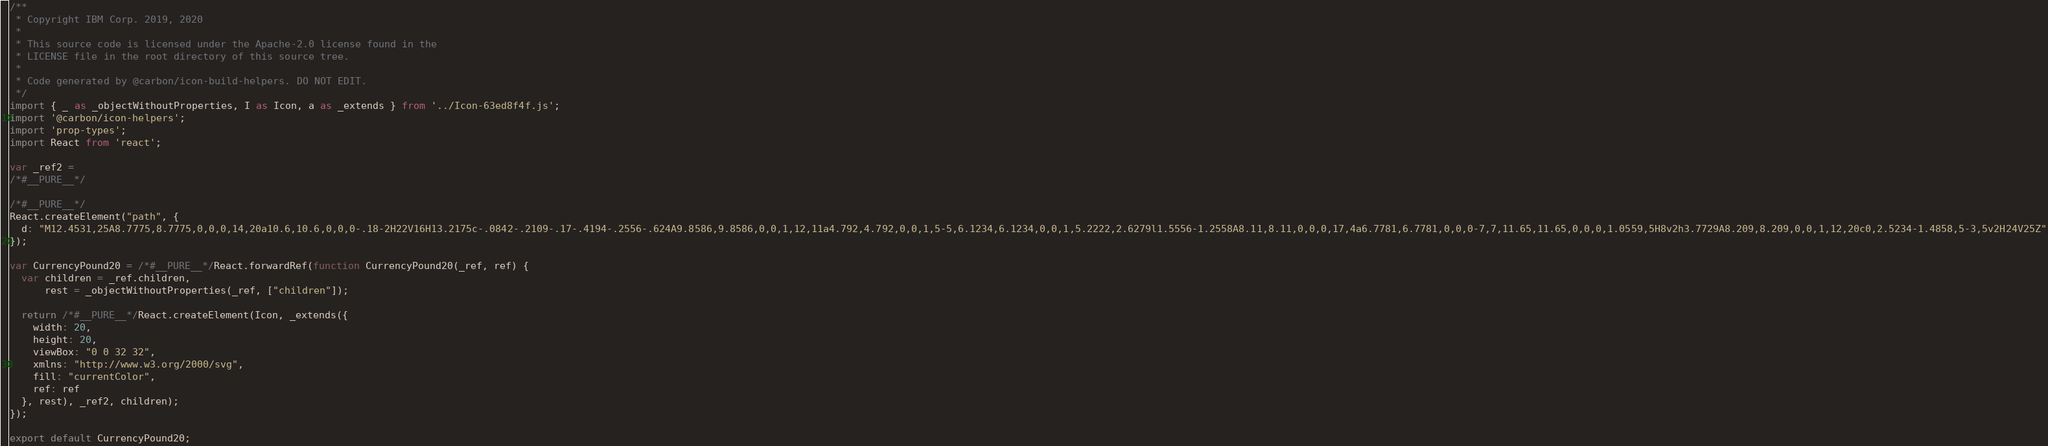<code> <loc_0><loc_0><loc_500><loc_500><_JavaScript_>/**
 * Copyright IBM Corp. 2019, 2020
 *
 * This source code is licensed under the Apache-2.0 license found in the
 * LICENSE file in the root directory of this source tree.
 *
 * Code generated by @carbon/icon-build-helpers. DO NOT EDIT.
 */
import { _ as _objectWithoutProperties, I as Icon, a as _extends } from '../Icon-63ed8f4f.js';
import '@carbon/icon-helpers';
import 'prop-types';
import React from 'react';

var _ref2 =
/*#__PURE__*/

/*#__PURE__*/
React.createElement("path", {
  d: "M12.4531,25A8.7775,8.7775,0,0,0,14,20a10.6,10.6,0,0,0-.18-2H22V16H13.2175c-.0842-.2109-.17-.4194-.2556-.624A9.8586,9.8586,0,0,1,12,11a4.792,4.792,0,0,1,5-5,6.1234,6.1234,0,0,1,5.2222,2.6279l1.5556-1.2558A8.11,8.11,0,0,0,17,4a6.7781,6.7781,0,0,0-7,7,11.65,11.65,0,0,0,1.0559,5H8v2h3.7729A8.209,8.209,0,0,1,12,20c0,2.5234-1.4858,5-3,5v2H24V25Z"
});

var CurrencyPound20 = /*#__PURE__*/React.forwardRef(function CurrencyPound20(_ref, ref) {
  var children = _ref.children,
      rest = _objectWithoutProperties(_ref, ["children"]);

  return /*#__PURE__*/React.createElement(Icon, _extends({
    width: 20,
    height: 20,
    viewBox: "0 0 32 32",
    xmlns: "http://www.w3.org/2000/svg",
    fill: "currentColor",
    ref: ref
  }, rest), _ref2, children);
});

export default CurrencyPound20;
</code> 